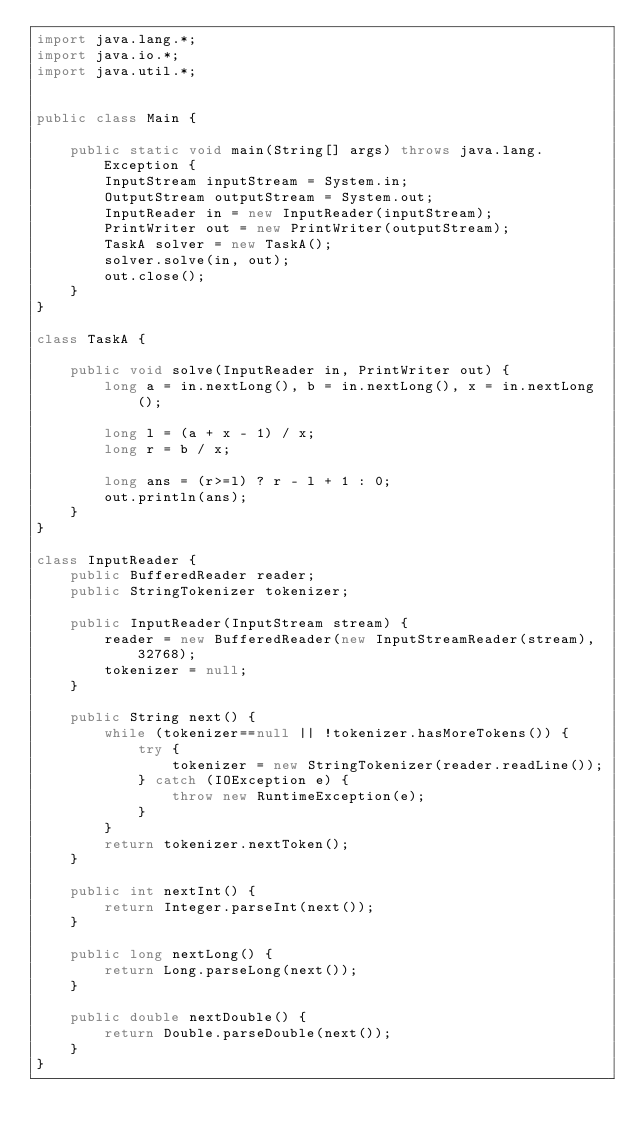<code> <loc_0><loc_0><loc_500><loc_500><_Java_>import java.lang.*;
import java.io.*;
import java.util.*;


public class Main {
	
	public static void main(String[] args) throws java.lang.Exception {
		InputStream inputStream = System.in;
		OutputStream outputStream = System.out;
		InputReader in = new InputReader(inputStream);
		PrintWriter out = new PrintWriter(outputStream);
		TaskA solver = new TaskA();
		solver.solve(in, out);
		out.close();
	}
}

class TaskA {
	
	public void solve(InputReader in, PrintWriter out) {
		long a = in.nextLong(), b = in.nextLong(), x = in.nextLong();
		
		long l = (a + x - 1) / x;
		long r = b / x;
		
		long ans = (r>=l) ? r - l + 1 : 0;
		out.println(ans);
	}
}

class InputReader {
	public BufferedReader reader;
	public StringTokenizer tokenizer;
	
	public InputReader(InputStream stream) {
		reader = new BufferedReader(new InputStreamReader(stream), 32768);
		tokenizer = null;
	}
	
	public String next() {
		while (tokenizer==null || !tokenizer.hasMoreTokens()) {
			try {
				tokenizer = new StringTokenizer(reader.readLine());
			} catch (IOException e) {
				throw new RuntimeException(e);
			}
		}
		return tokenizer.nextToken();
	}
	
	public int nextInt() {
		return Integer.parseInt(next());
	}
	
	public long nextLong() {
		return Long.parseLong(next());
	}
	
	public double nextDouble() {
		return Double.parseDouble(next());
	}
}</code> 